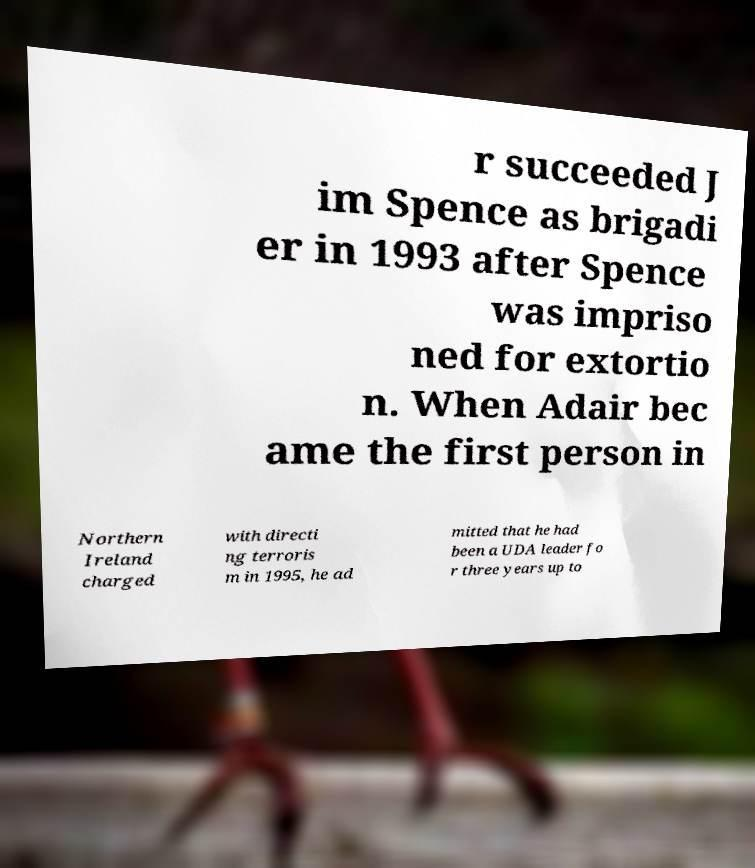Can you accurately transcribe the text from the provided image for me? r succeeded J im Spence as brigadi er in 1993 after Spence was impriso ned for extortio n. When Adair bec ame the first person in Northern Ireland charged with directi ng terroris m in 1995, he ad mitted that he had been a UDA leader fo r three years up to 